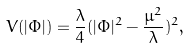Convert formula to latex. <formula><loc_0><loc_0><loc_500><loc_500>V ( | \Phi | ) = \frac { \lambda } { 4 } ( | \Phi | ^ { 2 } - \frac { \mu ^ { 2 } } { \lambda } ) ^ { 2 } ,</formula> 